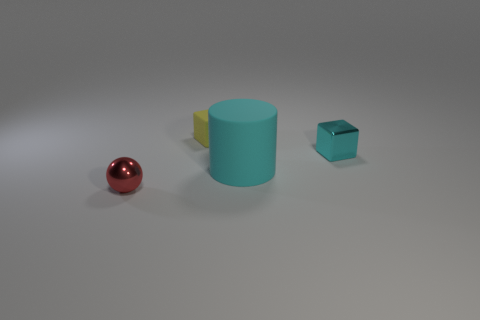Add 2 yellow matte objects. How many objects exist? 6 Subtract all small yellow rubber blocks. Subtract all big blue rubber blocks. How many objects are left? 3 Add 4 tiny spheres. How many tiny spheres are left? 5 Add 1 large yellow rubber cylinders. How many large yellow rubber cylinders exist? 1 Subtract 0 gray cylinders. How many objects are left? 4 